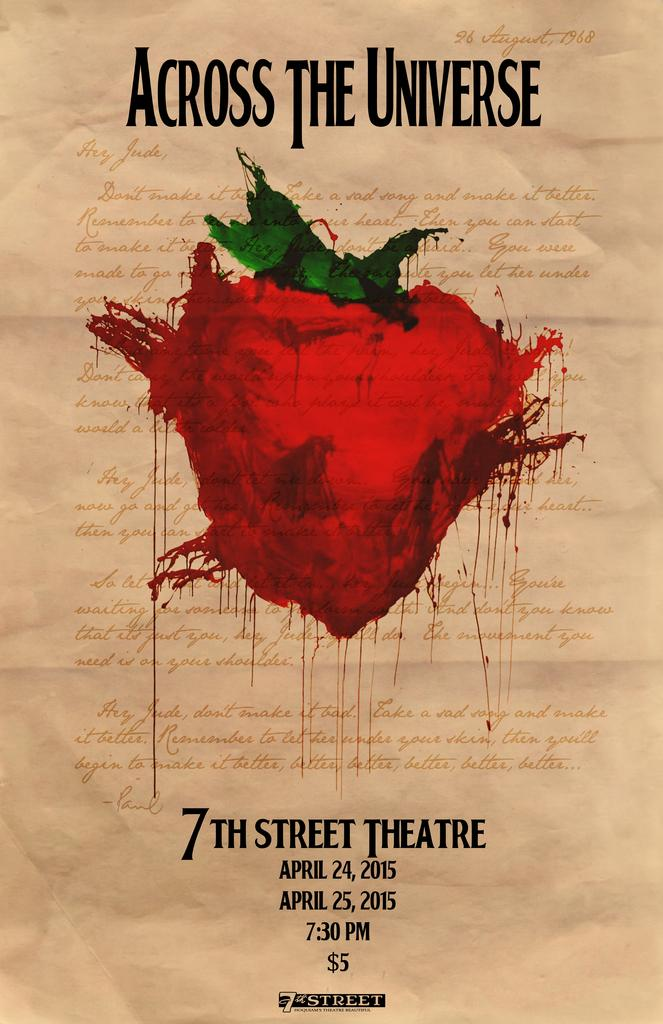Provide a one-sentence caption for the provided image. Across The Universe was showing at the 7th Street Theatre for $5. 